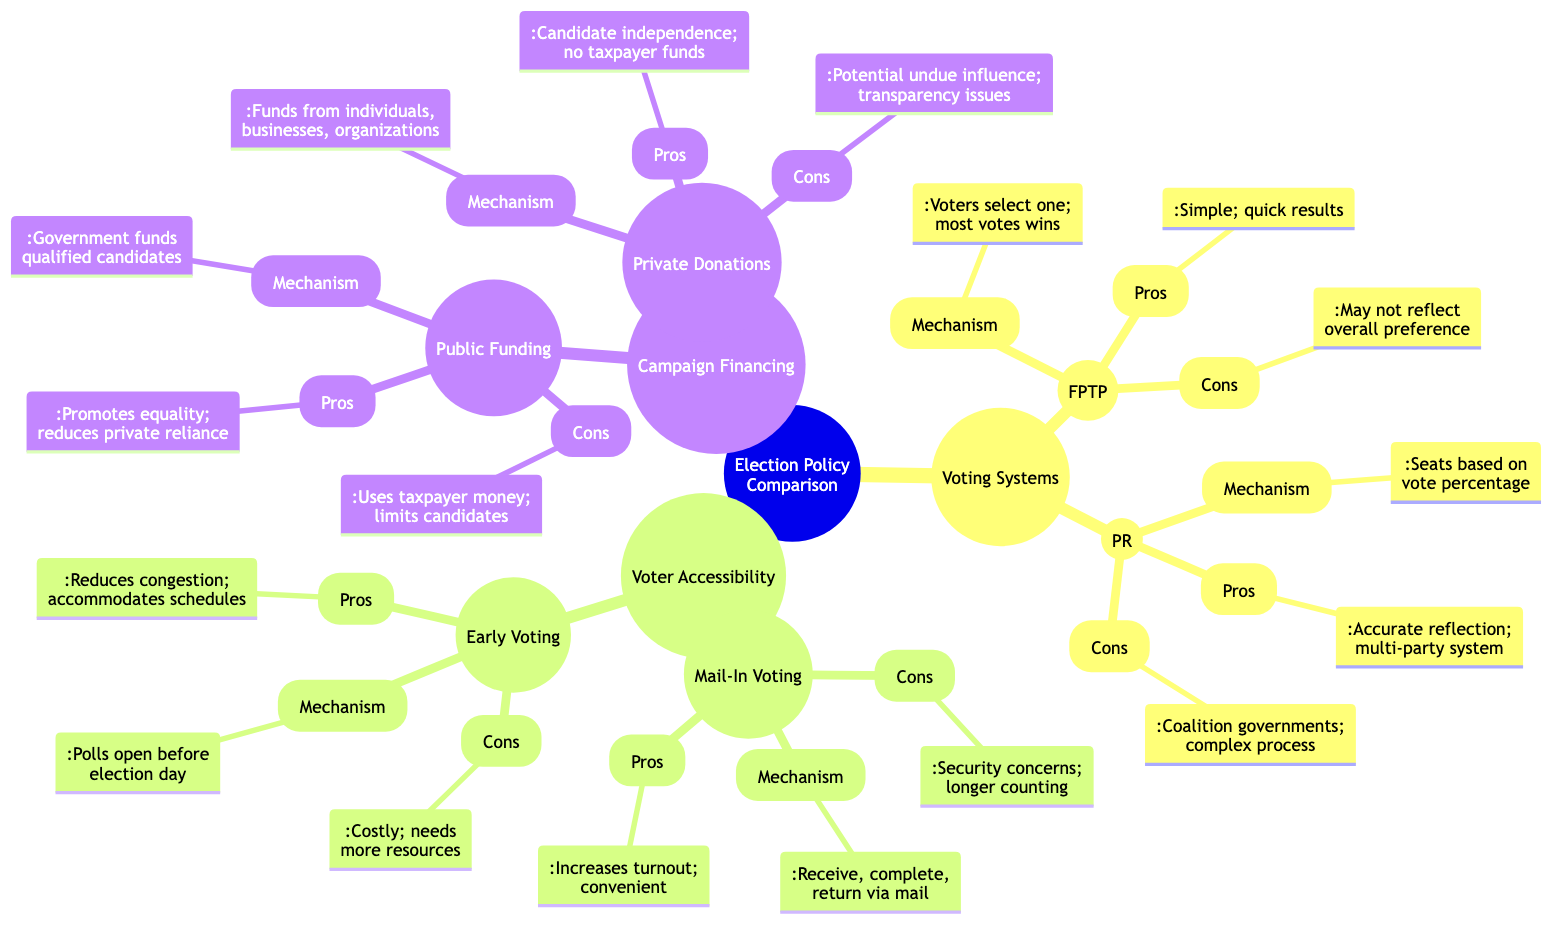What is the mechanism for First-Past-The-Post? The diagram states that in the First-Past-The-Post mechanism, voters select one candidate, and the candidate with the most votes wins.
Answer: Voters select one candidate; candidate with the most votes wins How many main branches are there in the diagram? The diagram has three main branches: Voting Systems, Voter Accessibility, and Campaign Financing.
Answer: Three What is a pro of Proportional Representation? The diagram indicates that a pro of Proportional Representation is that it provides a more accurate reflection of voter preferences.
Answer: More accurate reflection of voter preferences What is a con of Mail-In Voting? According to the diagram, a con of Mail-In Voting is concerns about security and fraud.
Answer: Concerns about security and fraud How does Early Voting affect congestion on election day? The diagram explains that Early Voting reduces congestion on election day, since polling stations are open before the official election day.
Answer: Reduces congestion on election day What are the two mechanisms for campaign financing mentioned? The diagram lists Public Funding and Private Donations as the two mechanisms for campaign financing.
Answer: Public Funding and Private Donations What is a pro of Public Funding? The diagram states that a pro of Public Funding is that it promotes equality among candidates.
Answer: Promotes equality among candidates What potential issue is linked to Private Donations? The diagram mentions the potential issue of undue influence from wealthy donors associated with Private Donations.
Answer: Potential for undue influence from wealthy donors What common concern is raised about mail-in voting and early voting? The diagram mentions security concerns for mail-in voting and cost/resources for early voting, highlighting concerns about accessibility and eligibility.
Answer: Security concerns and cost 